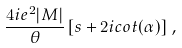<formula> <loc_0><loc_0><loc_500><loc_500>\frac { 4 i e ^ { 2 } | M | } { \theta } \left [ s + 2 i c o t ( \alpha ) \right ] \, ,</formula> 